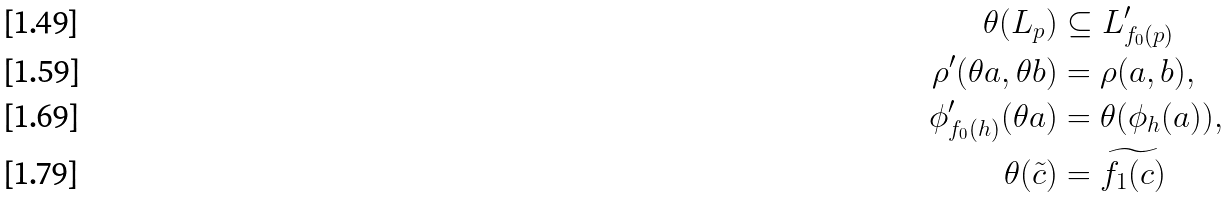<formula> <loc_0><loc_0><loc_500><loc_500>\theta ( L _ { p } ) & \subseteq L _ { f _ { 0 } ( p ) } ^ { \prime } \\ \rho ^ { \prime } ( \theta a , \theta b ) & = \rho ( a , b ) , \\ \phi ^ { \prime } _ { f _ { 0 } ( h ) } ( \theta a ) & = \theta ( \phi _ { h } ( a ) ) , \\ \theta ( \tilde { c } ) & = \widetilde { f _ { 1 } ( c ) }</formula> 